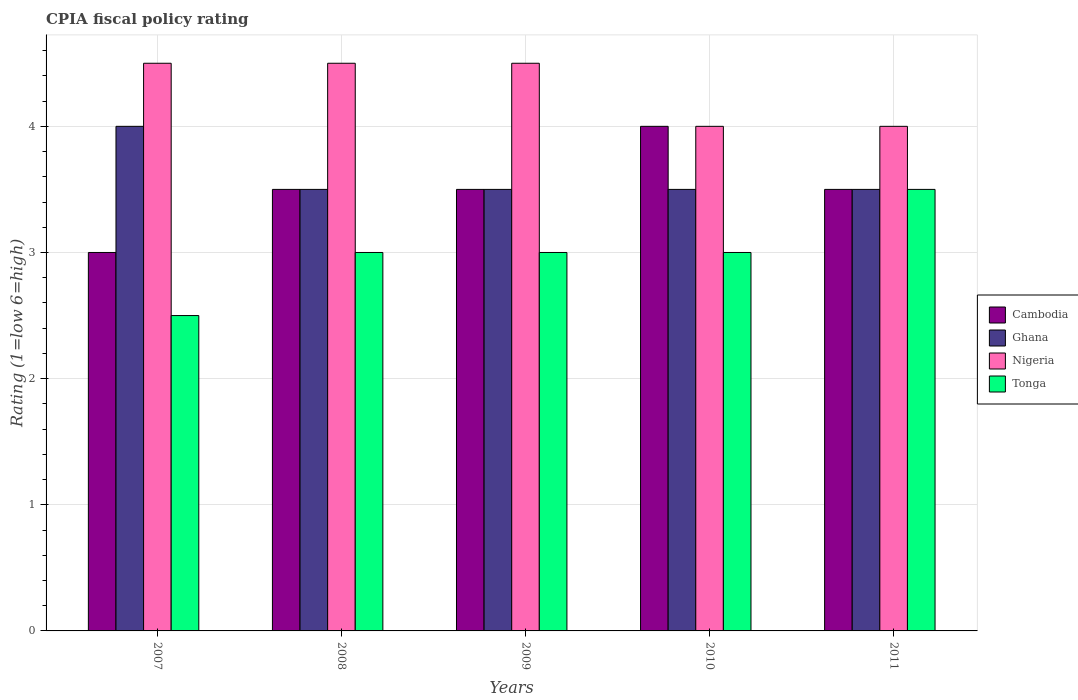In how many cases, is the number of bars for a given year not equal to the number of legend labels?
Make the answer very short. 0. Across all years, what is the maximum CPIA rating in Ghana?
Provide a short and direct response. 4. Across all years, what is the minimum CPIA rating in Cambodia?
Provide a short and direct response. 3. What is the difference between the CPIA rating in Ghana in 2007 and that in 2008?
Your answer should be very brief. 0.5. What is the average CPIA rating in Tonga per year?
Your response must be concise. 3. In the year 2009, what is the difference between the CPIA rating in Cambodia and CPIA rating in Tonga?
Your answer should be compact. 0.5. In how many years, is the CPIA rating in Nigeria greater than 4?
Keep it short and to the point. 3. What is the ratio of the CPIA rating in Cambodia in 2007 to that in 2008?
Offer a very short reply. 0.86. Is the difference between the CPIA rating in Cambodia in 2008 and 2009 greater than the difference between the CPIA rating in Tonga in 2008 and 2009?
Provide a succinct answer. No. What is the difference between the highest and the second highest CPIA rating in Nigeria?
Keep it short and to the point. 0. What is the difference between the highest and the lowest CPIA rating in Tonga?
Provide a short and direct response. 1. In how many years, is the CPIA rating in Tonga greater than the average CPIA rating in Tonga taken over all years?
Offer a terse response. 1. Is the sum of the CPIA rating in Cambodia in 2008 and 2010 greater than the maximum CPIA rating in Ghana across all years?
Provide a succinct answer. Yes. What does the 1st bar from the right in 2008 represents?
Keep it short and to the point. Tonga. Is it the case that in every year, the sum of the CPIA rating in Nigeria and CPIA rating in Cambodia is greater than the CPIA rating in Ghana?
Keep it short and to the point. Yes. How many years are there in the graph?
Keep it short and to the point. 5. What is the difference between two consecutive major ticks on the Y-axis?
Ensure brevity in your answer.  1. Are the values on the major ticks of Y-axis written in scientific E-notation?
Ensure brevity in your answer.  No. Where does the legend appear in the graph?
Give a very brief answer. Center right. How many legend labels are there?
Provide a short and direct response. 4. How are the legend labels stacked?
Keep it short and to the point. Vertical. What is the title of the graph?
Provide a short and direct response. CPIA fiscal policy rating. Does "Barbados" appear as one of the legend labels in the graph?
Make the answer very short. No. What is the label or title of the X-axis?
Give a very brief answer. Years. What is the label or title of the Y-axis?
Ensure brevity in your answer.  Rating (1=low 6=high). What is the Rating (1=low 6=high) of Cambodia in 2007?
Your answer should be compact. 3. What is the Rating (1=low 6=high) of Nigeria in 2007?
Keep it short and to the point. 4.5. What is the Rating (1=low 6=high) in Tonga in 2007?
Make the answer very short. 2.5. What is the Rating (1=low 6=high) of Ghana in 2008?
Your response must be concise. 3.5. What is the Rating (1=low 6=high) of Nigeria in 2008?
Your answer should be compact. 4.5. What is the Rating (1=low 6=high) in Ghana in 2009?
Ensure brevity in your answer.  3.5. What is the Rating (1=low 6=high) of Ghana in 2010?
Ensure brevity in your answer.  3.5. What is the Rating (1=low 6=high) of Nigeria in 2010?
Provide a short and direct response. 4. What is the Rating (1=low 6=high) in Cambodia in 2011?
Keep it short and to the point. 3.5. Across all years, what is the maximum Rating (1=low 6=high) of Cambodia?
Your response must be concise. 4. Across all years, what is the minimum Rating (1=low 6=high) of Cambodia?
Ensure brevity in your answer.  3. What is the total Rating (1=low 6=high) in Ghana in the graph?
Your answer should be very brief. 18. What is the total Rating (1=low 6=high) in Nigeria in the graph?
Provide a succinct answer. 21.5. What is the difference between the Rating (1=low 6=high) of Cambodia in 2007 and that in 2008?
Your response must be concise. -0.5. What is the difference between the Rating (1=low 6=high) in Nigeria in 2007 and that in 2008?
Provide a succinct answer. 0. What is the difference between the Rating (1=low 6=high) of Tonga in 2007 and that in 2008?
Offer a very short reply. -0.5. What is the difference between the Rating (1=low 6=high) in Tonga in 2007 and that in 2009?
Provide a short and direct response. -0.5. What is the difference between the Rating (1=low 6=high) in Ghana in 2007 and that in 2010?
Provide a short and direct response. 0.5. What is the difference between the Rating (1=low 6=high) of Nigeria in 2007 and that in 2010?
Provide a short and direct response. 0.5. What is the difference between the Rating (1=low 6=high) in Ghana in 2007 and that in 2011?
Your response must be concise. 0.5. What is the difference between the Rating (1=low 6=high) in Nigeria in 2007 and that in 2011?
Offer a terse response. 0.5. What is the difference between the Rating (1=low 6=high) of Tonga in 2007 and that in 2011?
Provide a short and direct response. -1. What is the difference between the Rating (1=low 6=high) of Ghana in 2008 and that in 2009?
Offer a very short reply. 0. What is the difference between the Rating (1=low 6=high) of Cambodia in 2008 and that in 2010?
Give a very brief answer. -0.5. What is the difference between the Rating (1=low 6=high) in Ghana in 2008 and that in 2010?
Offer a very short reply. 0. What is the difference between the Rating (1=low 6=high) in Nigeria in 2008 and that in 2010?
Make the answer very short. 0.5. What is the difference between the Rating (1=low 6=high) in Tonga in 2008 and that in 2010?
Offer a terse response. 0. What is the difference between the Rating (1=low 6=high) of Ghana in 2008 and that in 2011?
Give a very brief answer. 0. What is the difference between the Rating (1=low 6=high) of Nigeria in 2008 and that in 2011?
Your answer should be very brief. 0.5. What is the difference between the Rating (1=low 6=high) in Tonga in 2008 and that in 2011?
Your answer should be compact. -0.5. What is the difference between the Rating (1=low 6=high) of Ghana in 2009 and that in 2010?
Make the answer very short. 0. What is the difference between the Rating (1=low 6=high) in Nigeria in 2009 and that in 2010?
Keep it short and to the point. 0.5. What is the difference between the Rating (1=low 6=high) in Ghana in 2009 and that in 2011?
Your response must be concise. 0. What is the difference between the Rating (1=low 6=high) of Tonga in 2009 and that in 2011?
Keep it short and to the point. -0.5. What is the difference between the Rating (1=low 6=high) of Nigeria in 2010 and that in 2011?
Provide a succinct answer. 0. What is the difference between the Rating (1=low 6=high) of Tonga in 2010 and that in 2011?
Your response must be concise. -0.5. What is the difference between the Rating (1=low 6=high) in Cambodia in 2007 and the Rating (1=low 6=high) in Tonga in 2008?
Keep it short and to the point. 0. What is the difference between the Rating (1=low 6=high) of Ghana in 2007 and the Rating (1=low 6=high) of Nigeria in 2008?
Offer a very short reply. -0.5. What is the difference between the Rating (1=low 6=high) of Ghana in 2007 and the Rating (1=low 6=high) of Tonga in 2008?
Give a very brief answer. 1. What is the difference between the Rating (1=low 6=high) in Nigeria in 2007 and the Rating (1=low 6=high) in Tonga in 2008?
Provide a short and direct response. 1.5. What is the difference between the Rating (1=low 6=high) of Ghana in 2007 and the Rating (1=low 6=high) of Tonga in 2009?
Your response must be concise. 1. What is the difference between the Rating (1=low 6=high) in Nigeria in 2007 and the Rating (1=low 6=high) in Tonga in 2009?
Offer a terse response. 1.5. What is the difference between the Rating (1=low 6=high) in Cambodia in 2007 and the Rating (1=low 6=high) in Ghana in 2010?
Offer a very short reply. -0.5. What is the difference between the Rating (1=low 6=high) of Cambodia in 2007 and the Rating (1=low 6=high) of Tonga in 2010?
Keep it short and to the point. 0. What is the difference between the Rating (1=low 6=high) of Ghana in 2007 and the Rating (1=low 6=high) of Nigeria in 2010?
Your answer should be very brief. 0. What is the difference between the Rating (1=low 6=high) in Ghana in 2007 and the Rating (1=low 6=high) in Tonga in 2010?
Provide a succinct answer. 1. What is the difference between the Rating (1=low 6=high) of Cambodia in 2007 and the Rating (1=low 6=high) of Ghana in 2011?
Make the answer very short. -0.5. What is the difference between the Rating (1=low 6=high) of Cambodia in 2007 and the Rating (1=low 6=high) of Nigeria in 2011?
Provide a succinct answer. -1. What is the difference between the Rating (1=low 6=high) in Cambodia in 2007 and the Rating (1=low 6=high) in Tonga in 2011?
Give a very brief answer. -0.5. What is the difference between the Rating (1=low 6=high) in Ghana in 2007 and the Rating (1=low 6=high) in Nigeria in 2011?
Offer a terse response. 0. What is the difference between the Rating (1=low 6=high) in Nigeria in 2007 and the Rating (1=low 6=high) in Tonga in 2011?
Provide a short and direct response. 1. What is the difference between the Rating (1=low 6=high) of Cambodia in 2008 and the Rating (1=low 6=high) of Tonga in 2009?
Your response must be concise. 0.5. What is the difference between the Rating (1=low 6=high) in Cambodia in 2008 and the Rating (1=low 6=high) in Ghana in 2010?
Ensure brevity in your answer.  0. What is the difference between the Rating (1=low 6=high) in Cambodia in 2008 and the Rating (1=low 6=high) in Tonga in 2010?
Make the answer very short. 0.5. What is the difference between the Rating (1=low 6=high) of Cambodia in 2008 and the Rating (1=low 6=high) of Ghana in 2011?
Give a very brief answer. 0. What is the difference between the Rating (1=low 6=high) of Cambodia in 2008 and the Rating (1=low 6=high) of Tonga in 2011?
Keep it short and to the point. 0. What is the difference between the Rating (1=low 6=high) in Ghana in 2008 and the Rating (1=low 6=high) in Tonga in 2011?
Provide a succinct answer. 0. What is the difference between the Rating (1=low 6=high) of Nigeria in 2008 and the Rating (1=low 6=high) of Tonga in 2011?
Your answer should be very brief. 1. What is the difference between the Rating (1=low 6=high) in Cambodia in 2009 and the Rating (1=low 6=high) in Tonga in 2010?
Provide a succinct answer. 0.5. What is the difference between the Rating (1=low 6=high) in Ghana in 2009 and the Rating (1=low 6=high) in Nigeria in 2010?
Provide a short and direct response. -0.5. What is the difference between the Rating (1=low 6=high) of Nigeria in 2009 and the Rating (1=low 6=high) of Tonga in 2010?
Your answer should be very brief. 1.5. What is the difference between the Rating (1=low 6=high) of Cambodia in 2009 and the Rating (1=low 6=high) of Nigeria in 2011?
Give a very brief answer. -0.5. What is the difference between the Rating (1=low 6=high) of Cambodia in 2009 and the Rating (1=low 6=high) of Tonga in 2011?
Make the answer very short. 0. What is the difference between the Rating (1=low 6=high) of Ghana in 2009 and the Rating (1=low 6=high) of Tonga in 2011?
Provide a short and direct response. 0. What is the difference between the Rating (1=low 6=high) in Nigeria in 2009 and the Rating (1=low 6=high) in Tonga in 2011?
Provide a short and direct response. 1. What is the difference between the Rating (1=low 6=high) of Cambodia in 2010 and the Rating (1=low 6=high) of Ghana in 2011?
Give a very brief answer. 0.5. What is the difference between the Rating (1=low 6=high) of Cambodia in 2010 and the Rating (1=low 6=high) of Nigeria in 2011?
Your response must be concise. 0. What is the difference between the Rating (1=low 6=high) of Ghana in 2010 and the Rating (1=low 6=high) of Nigeria in 2011?
Offer a very short reply. -0.5. What is the average Rating (1=low 6=high) in Tonga per year?
Offer a terse response. 3. In the year 2007, what is the difference between the Rating (1=low 6=high) of Cambodia and Rating (1=low 6=high) of Nigeria?
Offer a very short reply. -1.5. In the year 2007, what is the difference between the Rating (1=low 6=high) in Cambodia and Rating (1=low 6=high) in Tonga?
Your answer should be compact. 0.5. In the year 2007, what is the difference between the Rating (1=low 6=high) of Ghana and Rating (1=low 6=high) of Tonga?
Offer a very short reply. 1.5. In the year 2008, what is the difference between the Rating (1=low 6=high) in Cambodia and Rating (1=low 6=high) in Tonga?
Ensure brevity in your answer.  0.5. In the year 2008, what is the difference between the Rating (1=low 6=high) of Ghana and Rating (1=low 6=high) of Nigeria?
Ensure brevity in your answer.  -1. In the year 2009, what is the difference between the Rating (1=low 6=high) of Cambodia and Rating (1=low 6=high) of Ghana?
Your answer should be very brief. 0. In the year 2009, what is the difference between the Rating (1=low 6=high) of Cambodia and Rating (1=low 6=high) of Nigeria?
Your response must be concise. -1. In the year 2009, what is the difference between the Rating (1=low 6=high) in Cambodia and Rating (1=low 6=high) in Tonga?
Provide a short and direct response. 0.5. In the year 2010, what is the difference between the Rating (1=low 6=high) in Cambodia and Rating (1=low 6=high) in Nigeria?
Give a very brief answer. 0. In the year 2010, what is the difference between the Rating (1=low 6=high) in Cambodia and Rating (1=low 6=high) in Tonga?
Give a very brief answer. 1. In the year 2010, what is the difference between the Rating (1=low 6=high) in Ghana and Rating (1=low 6=high) in Nigeria?
Keep it short and to the point. -0.5. In the year 2010, what is the difference between the Rating (1=low 6=high) of Ghana and Rating (1=low 6=high) of Tonga?
Provide a short and direct response. 0.5. In the year 2011, what is the difference between the Rating (1=low 6=high) of Cambodia and Rating (1=low 6=high) of Ghana?
Offer a terse response. 0. In the year 2011, what is the difference between the Rating (1=low 6=high) in Cambodia and Rating (1=low 6=high) in Nigeria?
Make the answer very short. -0.5. In the year 2011, what is the difference between the Rating (1=low 6=high) in Ghana and Rating (1=low 6=high) in Tonga?
Ensure brevity in your answer.  0. In the year 2011, what is the difference between the Rating (1=low 6=high) of Nigeria and Rating (1=low 6=high) of Tonga?
Your answer should be compact. 0.5. What is the ratio of the Rating (1=low 6=high) in Ghana in 2007 to that in 2008?
Give a very brief answer. 1.14. What is the ratio of the Rating (1=low 6=high) in Nigeria in 2007 to that in 2008?
Offer a terse response. 1. What is the ratio of the Rating (1=low 6=high) in Tonga in 2007 to that in 2009?
Provide a short and direct response. 0.83. What is the ratio of the Rating (1=low 6=high) of Tonga in 2007 to that in 2010?
Your response must be concise. 0.83. What is the ratio of the Rating (1=low 6=high) of Ghana in 2007 to that in 2011?
Provide a short and direct response. 1.14. What is the ratio of the Rating (1=low 6=high) of Tonga in 2007 to that in 2011?
Provide a short and direct response. 0.71. What is the ratio of the Rating (1=low 6=high) of Nigeria in 2008 to that in 2009?
Provide a short and direct response. 1. What is the ratio of the Rating (1=low 6=high) in Ghana in 2008 to that in 2011?
Offer a terse response. 1. What is the ratio of the Rating (1=low 6=high) in Tonga in 2008 to that in 2011?
Give a very brief answer. 0.86. What is the ratio of the Rating (1=low 6=high) in Cambodia in 2009 to that in 2010?
Your response must be concise. 0.88. What is the ratio of the Rating (1=low 6=high) of Ghana in 2009 to that in 2011?
Make the answer very short. 1. What is the ratio of the Rating (1=low 6=high) in Nigeria in 2009 to that in 2011?
Provide a succinct answer. 1.12. What is the ratio of the Rating (1=low 6=high) of Cambodia in 2010 to that in 2011?
Your response must be concise. 1.14. What is the ratio of the Rating (1=low 6=high) of Tonga in 2010 to that in 2011?
Your response must be concise. 0.86. What is the difference between the highest and the second highest Rating (1=low 6=high) of Cambodia?
Give a very brief answer. 0.5. What is the difference between the highest and the second highest Rating (1=low 6=high) of Ghana?
Offer a very short reply. 0.5. What is the difference between the highest and the second highest Rating (1=low 6=high) in Nigeria?
Your response must be concise. 0. What is the difference between the highest and the second highest Rating (1=low 6=high) in Tonga?
Make the answer very short. 0.5. What is the difference between the highest and the lowest Rating (1=low 6=high) of Cambodia?
Make the answer very short. 1. What is the difference between the highest and the lowest Rating (1=low 6=high) in Ghana?
Provide a succinct answer. 0.5. What is the difference between the highest and the lowest Rating (1=low 6=high) in Nigeria?
Provide a succinct answer. 0.5. What is the difference between the highest and the lowest Rating (1=low 6=high) in Tonga?
Your answer should be very brief. 1. 